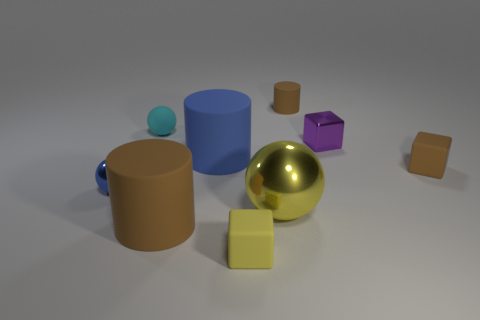There is a small object that is behind the purple shiny object and to the left of the big brown thing; what color is it?
Provide a succinct answer. Cyan. Do the rubber thing to the right of the purple shiny block and the small matte cylinder have the same color?
Provide a short and direct response. Yes. The blue object that is the same size as the brown rubber block is what shape?
Your answer should be very brief. Sphere. What number of other things are there of the same color as the small cylinder?
Your response must be concise. 2. What number of other things are there of the same material as the big ball
Provide a succinct answer. 2. There is a blue sphere; does it have the same size as the brown matte cylinder in front of the tiny cyan thing?
Give a very brief answer. No. The big shiny sphere has what color?
Offer a very short reply. Yellow. There is a yellow matte object that is to the right of the big rubber cylinder behind the yellow thing that is behind the yellow rubber block; what is its shape?
Offer a very short reply. Cube. What is the material of the small block to the left of the cylinder on the right side of the tiny yellow cube?
Offer a very short reply. Rubber. There is a big brown thing that is made of the same material as the tiny cyan ball; what shape is it?
Provide a short and direct response. Cylinder. 